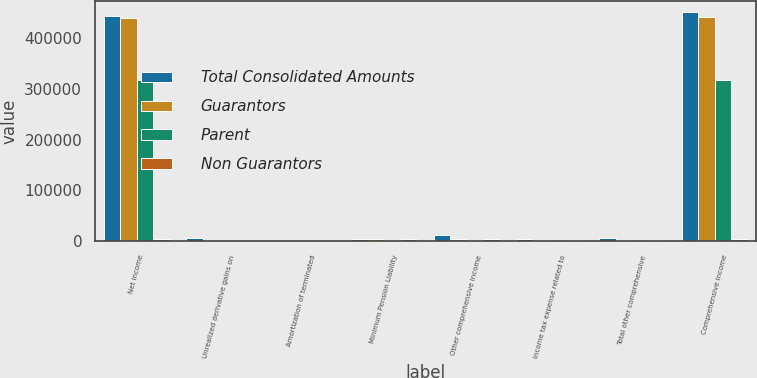<chart> <loc_0><loc_0><loc_500><loc_500><stacked_bar_chart><ecel><fcel>Net income<fcel>Unrealized derivative gains on<fcel>Amortization of terminated<fcel>Minimum Pension Liability<fcel>Other comprehensive income<fcel>Income tax expense related to<fcel>Total other comprehensive<fcel>Comprehensive income<nl><fcel>Total Consolidated Amounts<fcel>443446<fcel>6677<fcel>336<fcel>4986<fcel>11327<fcel>4306<fcel>7021<fcel>450467<nl><fcel>Guarantors<fcel>438873<fcel>0<fcel>0<fcel>4986<fcel>4986<fcel>1898<fcel>3088<fcel>441961<nl><fcel>Parent<fcel>316617<fcel>0<fcel>0<fcel>0<fcel>0<fcel>0<fcel>0<fcel>316617<nl><fcel>Non Guarantors<fcel>3697<fcel>0<fcel>0<fcel>4986<fcel>4986<fcel>1898<fcel>3088<fcel>3697<nl></chart> 